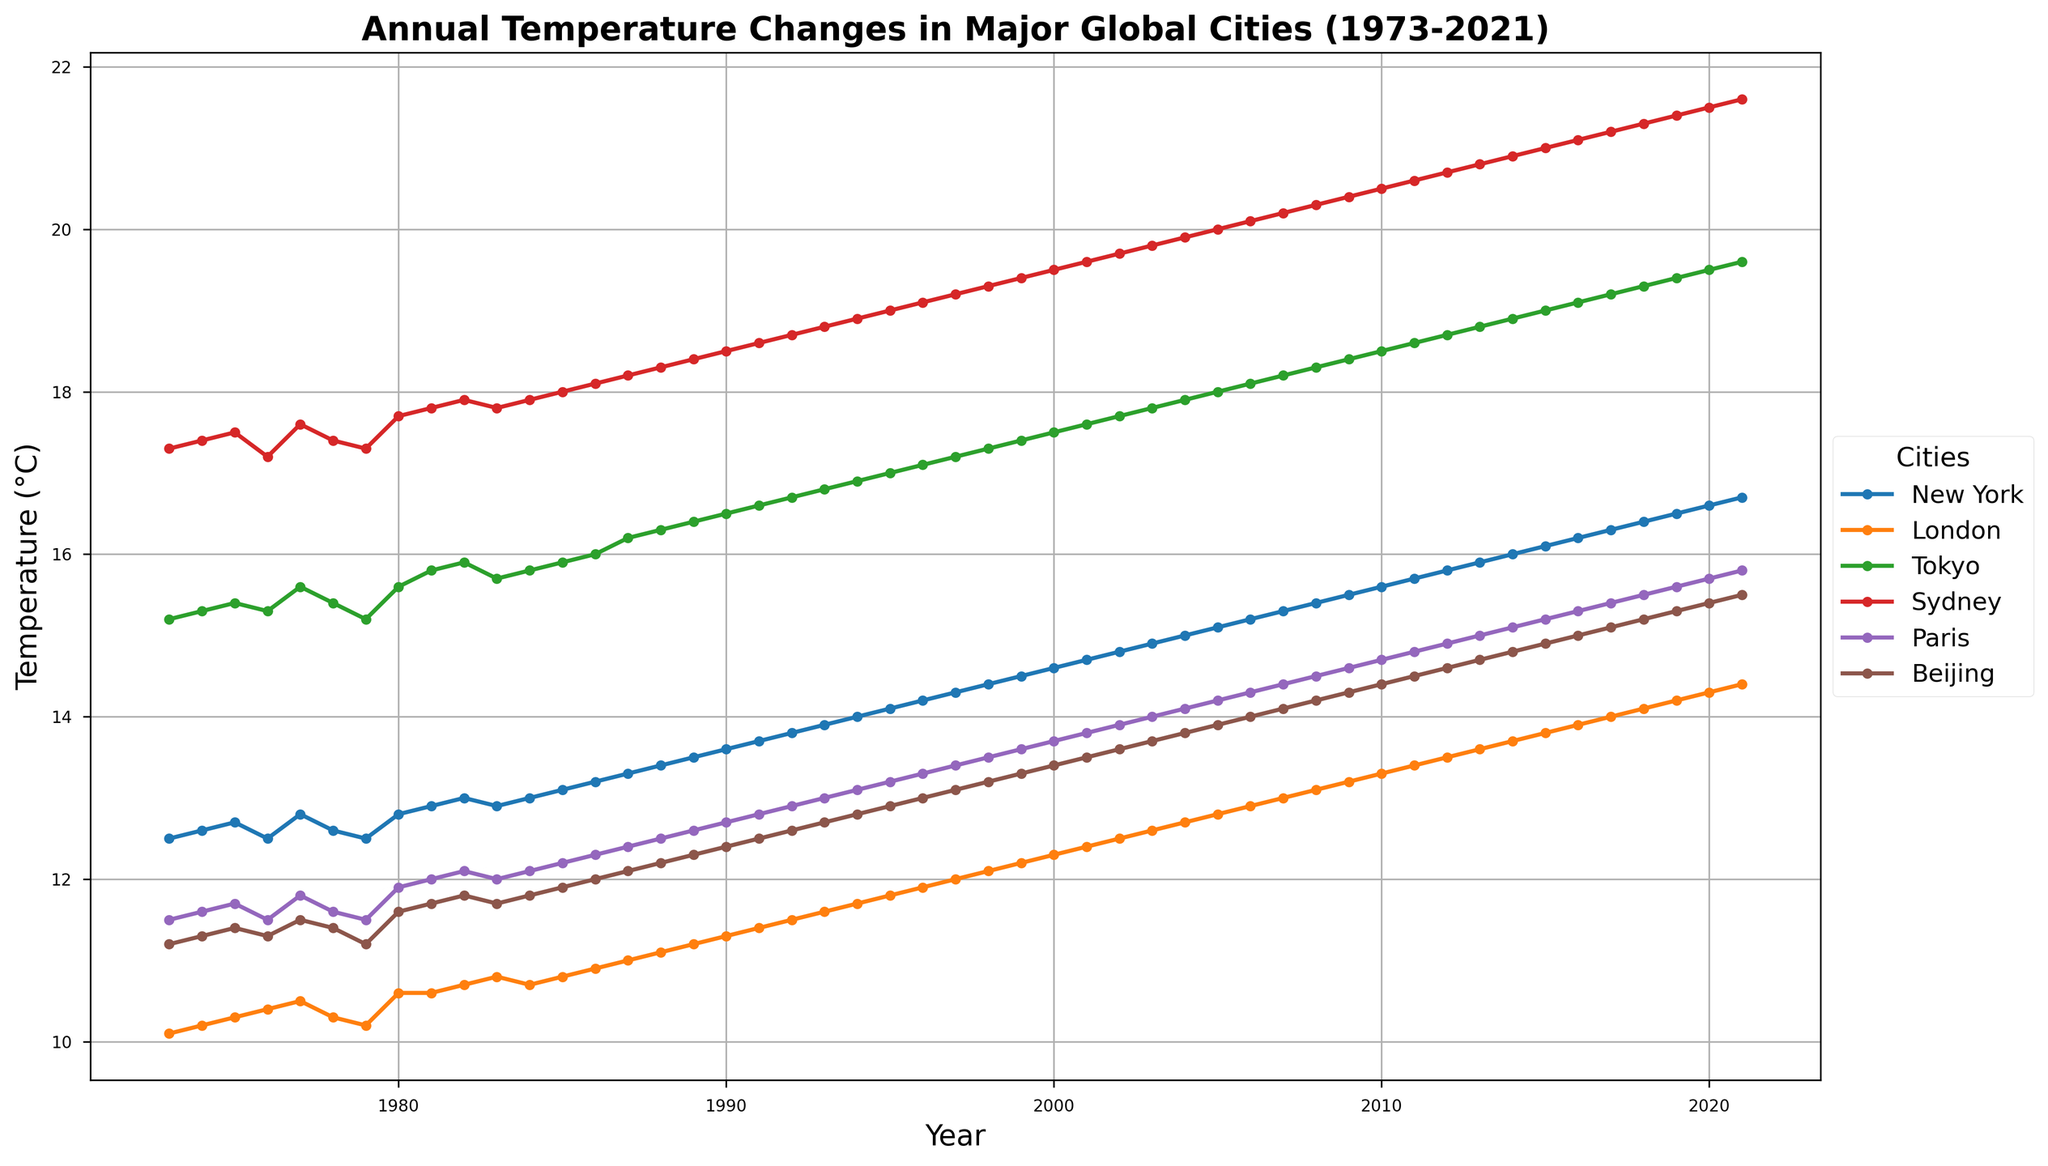What's the overall trend in the temperatures of New York over the 50-year period? To determine the trend, observe the line for New York on the plot. The line starts at 12.5°C in 1973 and increases continually to 16.7°C in 2021, indicating an upward trend.
Answer: Increasing trend Which city has the highest temperature in 2021? Locate the data points for the year 2021 and compare the heights of all the lines. Sydney has the highest temperature at 21.6°C.
Answer: Sydney Which city experienced the largest temperature increase from 1973 to 2021? For each city, calculate the difference in temperatures between 2021 and 1973. Compare these differences. Sydney's increase is (21.6 - 17.3)=4.3°C, New York's increase is (16.7 - 12.5)=4.2°C, and similar calculations for others show Sydney has the largest increase.
Answer: Sydney Did any city's temperature decrease over the 50-year period? Observe all the lines on the plot to see if any of them slope downward from left (1973) to right (2021). None of the cities shows a decreasing trend, indicating all experienced temperature increases.
Answer: No How does Beijing's temperature in 1980 compare to Paris's temperature in the same year? Locate the data points for Beijing and Paris in 1980 and compare the heights. Beijing's temperature in 1980 is 11.6°C, and Paris's is 11.9°C, so Paris is slightly warmer.
Answer: Paris is warmer How much higher is the temperature increase in Tokyo compared to London from 1973 to 2021? Calculate each city's temperature increase: Tokyo's increase= (19.6-15.2)=4.4°C, and London's increase= (14.4-10.1)=4.3°C. The difference between Tokyo's increase and London's increase is 4.4-4.3=0.1°C.
Answer: 0.1°C higher Which city had the most stable (least variable) temperature over the years? The city with the least fluctuation in its line graph indicates the most stable temperature. London's line appears the least variable within a narrow range over the years.
Answer: London What is the average annual temperature for Paris over the 50 years? Add the temperatures for Paris from 1973 to 2021 and divide by 50. The calculation is complex, and an exact average would require precise data summing and division.
Answer: Roughly mid-range increase Between which two years did New York see the steepest increase in temperature? Look for the segment of the New York line that shows the steepest upward slope, indicating the largest temperature change. This seems most prominent from the mid-1980s to early 1990s. Exact years require closer inspection of line steepness.
Answer: Mid-1980s to early 1990s 